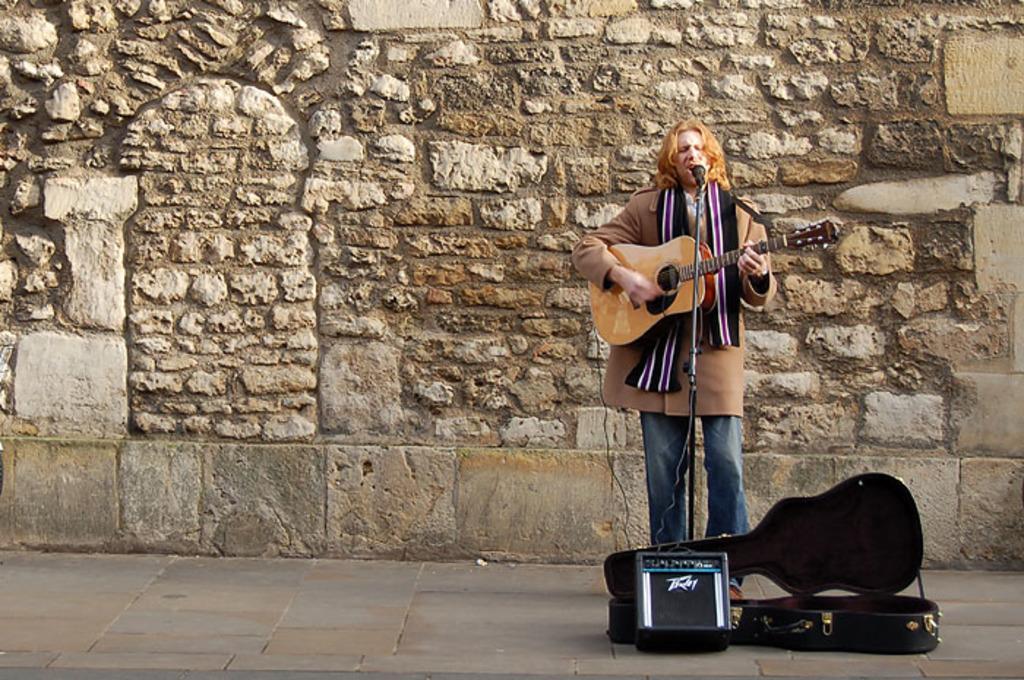Describe this image in one or two sentences. Here we can see a man standing on the floor, and singing and playing the guitar, and here is the wall. 